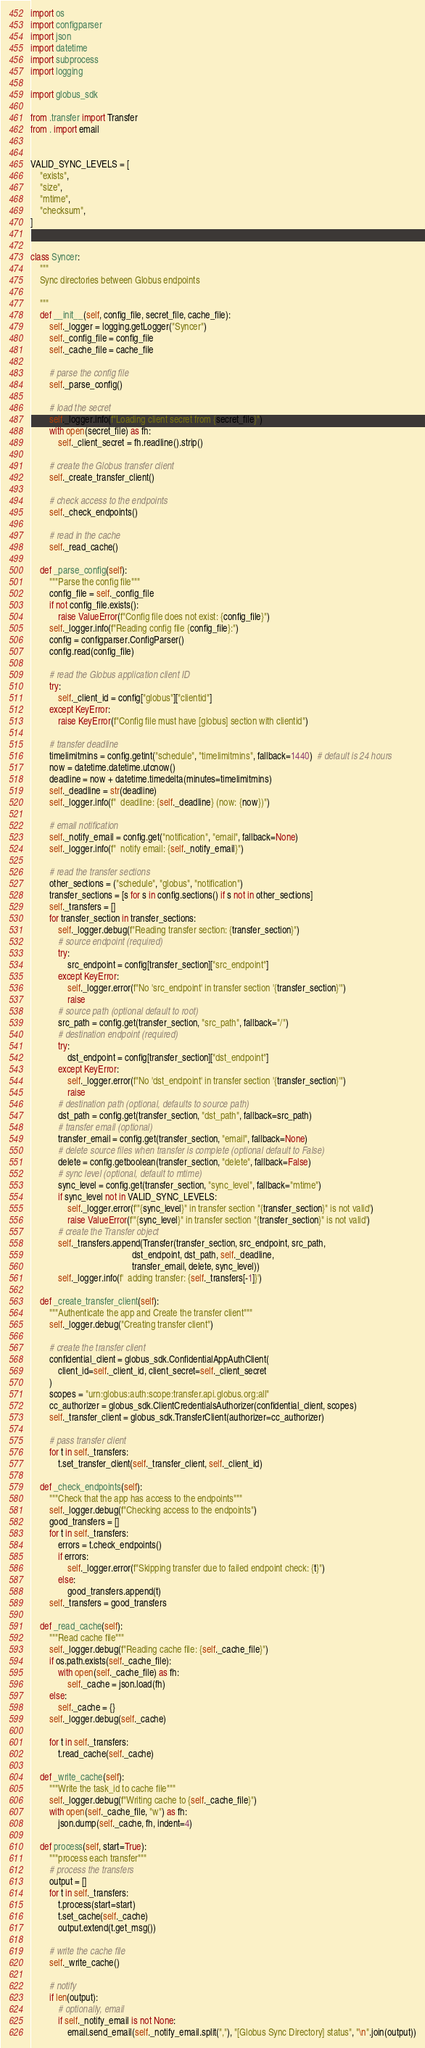<code> <loc_0><loc_0><loc_500><loc_500><_Python_>
import os
import configparser
import json
import datetime
import subprocess
import logging

import globus_sdk

from .transfer import Transfer
from . import email


VALID_SYNC_LEVELS = [
    "exists",
    "size",
    "mtime",
    "checksum",
]


class Syncer:
    """
    Sync directories between Globus endpoints

    """
    def __init__(self, config_file, secret_file, cache_file):
        self._logger = logging.getLogger("Syncer")
        self._config_file = config_file
        self._cache_file = cache_file

        # parse the config file
        self._parse_config()

        # load the secret
        self._logger.info(f"Loading client secret from {secret_file}")
        with open(secret_file) as fh:
            self._client_secret = fh.readline().strip()

        # create the Globus transfer client
        self._create_transfer_client()

        # check access to the endpoints
        self._check_endpoints()

        # read in the cache
        self._read_cache()

    def _parse_config(self):
        """Parse the config file"""
        config_file = self._config_file
        if not config_file.exists():
            raise ValueError(f"Config file does not exist: {config_file}")
        self._logger.info(f"Reading config file {config_file}:")
        config = configparser.ConfigParser()
        config.read(config_file)

        # read the Globus application client ID
        try:
            self._client_id = config["globus"]["clientid"]
        except KeyError:
            raise KeyError(f"Config file must have [globus] section with clientid")

        # transfer deadline
        timelimitmins = config.getint("schedule", "timelimitmins", fallback=1440)  # default is 24 hours
        now = datetime.datetime.utcnow()
        deadline = now + datetime.timedelta(minutes=timelimitmins)
        self._deadline = str(deadline)
        self._logger.info(f"  deadline: {self._deadline} (now: {now})")

        # email notification
        self._notify_email = config.get("notification", "email", fallback=None)
        self._logger.info(f"  notify email: {self._notify_email}")

        # read the transfer sections
        other_sections = ("schedule", "globus", "notification")
        transfer_sections = [s for s in config.sections() if s not in other_sections]
        self._transfers = []
        for transfer_section in transfer_sections:
            self._logger.debug(f"Reading transfer section: {transfer_section}")
            # source endpoint (required)
            try:
                src_endpoint = config[transfer_section]["src_endpoint"]
            except KeyError:
                self._logger.error(f"No 'src_endpoint' in transfer section '{transfer_section}'")
                raise
            # source path (optional default to root)
            src_path = config.get(transfer_section, "src_path", fallback="/")
            # destination endpoint (required)
            try:
                dst_endpoint = config[transfer_section]["dst_endpoint"]
            except KeyError:
                self._logger.error(f"No 'dst_endpoint' in transfer section '{transfer_section}'")
                raise
            # destination path (optional, defaults to source path)
            dst_path = config.get(transfer_section, "dst_path", fallback=src_path)
            # transfer email (optional)
            transfer_email = config.get(transfer_section, "email", fallback=None)
            # delete source files when transfer is complete (optional default to False)
            delete = config.getboolean(transfer_section, "delete", fallback=False)
            # sync level (optional, default to mtime)
            sync_level = config.get(transfer_section, "sync_level", fallback="mtime")
            if sync_level not in VALID_SYNC_LEVELS:
                self._logger.error(f'"{sync_level}" in transfer section "{transfer_section}" is not valid')
                raise ValueError(f'"{sync_level}" in transfer section "{transfer_section}" is not valid')
            # create the Transfer object
            self._transfers.append(Transfer(transfer_section, src_endpoint, src_path,
                                            dst_endpoint, dst_path, self._deadline,
                                            transfer_email, delete, sync_level))
            self._logger.info(f'  adding transfer: {self._transfers[-1]}')

    def _create_transfer_client(self):
        """Authenticate the app and Create the transfer client"""
        self._logger.debug("Creating transfer client")

        # create the transfer client
        confidential_client = globus_sdk.ConfidentialAppAuthClient(
            client_id=self._client_id, client_secret=self._client_secret
        )
        scopes = "urn:globus:auth:scope:transfer.api.globus.org:all"
        cc_authorizer = globus_sdk.ClientCredentialsAuthorizer(confidential_client, scopes)
        self._transfer_client = globus_sdk.TransferClient(authorizer=cc_authorizer)

        # pass transfer client
        for t in self._transfers:
            t.set_transfer_client(self._transfer_client, self._client_id)

    def _check_endpoints(self):
        """Check that the app has access to the endpoints"""
        self._logger.debug(f"Checking access to the endpoints")
        good_transfers = []
        for t in self._transfers:
            errors = t.check_endpoints()
            if errors:
                self._logger.error(f"Skipping transfer due to failed endpoint check: {t}")
            else:
                good_transfers.append(t)
        self._transfers = good_transfers

    def _read_cache(self):
        """Read cache file"""
        self._logger.debug(f"Reading cache file: {self._cache_file}")
        if os.path.exists(self._cache_file):
            with open(self._cache_file) as fh:
                self._cache = json.load(fh)
        else:
            self._cache = {}
        self._logger.debug(self._cache)

        for t in self._transfers:
            t.read_cache(self._cache)

    def _write_cache(self):
        """Write the task_id to cache file"""
        self._logger.debug(f"Writing cache to {self._cache_file}")
        with open(self._cache_file, "w") as fh:
            json.dump(self._cache, fh, indent=4)

    def process(self, start=True):
        """process each transfer"""
        # process the transfers
        output = []
        for t in self._transfers:
            t.process(start=start)
            t.set_cache(self._cache)
            output.extend(t.get_msg())

        # write the cache file
        self._write_cache()

        # notify
        if len(output):
            # optionally, email
            if self._notify_email is not None:
                email.send_email(self._notify_email.split(","), "[Globus Sync Directory] status", "\n".join(output))
</code> 